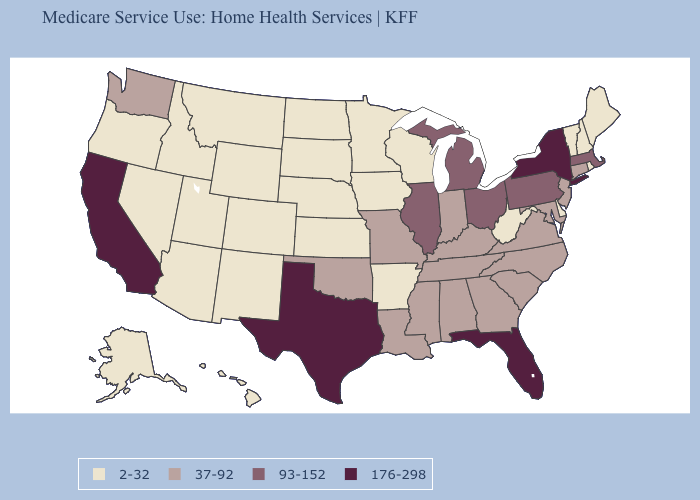What is the value of Kentucky?
Quick response, please. 37-92. What is the highest value in states that border Vermont?
Concise answer only. 176-298. Does South Carolina have a lower value than New York?
Quick response, please. Yes. Name the states that have a value in the range 176-298?
Quick response, please. California, Florida, New York, Texas. How many symbols are there in the legend?
Concise answer only. 4. Name the states that have a value in the range 2-32?
Be succinct. Alaska, Arizona, Arkansas, Colorado, Delaware, Hawaii, Idaho, Iowa, Kansas, Maine, Minnesota, Montana, Nebraska, Nevada, New Hampshire, New Mexico, North Dakota, Oregon, Rhode Island, South Dakota, Utah, Vermont, West Virginia, Wisconsin, Wyoming. What is the value of West Virginia?
Short answer required. 2-32. Name the states that have a value in the range 176-298?
Be succinct. California, Florida, New York, Texas. Among the states that border Massachusetts , does Connecticut have the highest value?
Write a very short answer. No. Does Alabama have a higher value than Idaho?
Concise answer only. Yes. What is the value of Alaska?
Write a very short answer. 2-32. How many symbols are there in the legend?
Short answer required. 4. Among the states that border Kentucky , does Illinois have the highest value?
Be succinct. Yes. Which states have the lowest value in the South?
Answer briefly. Arkansas, Delaware, West Virginia. 